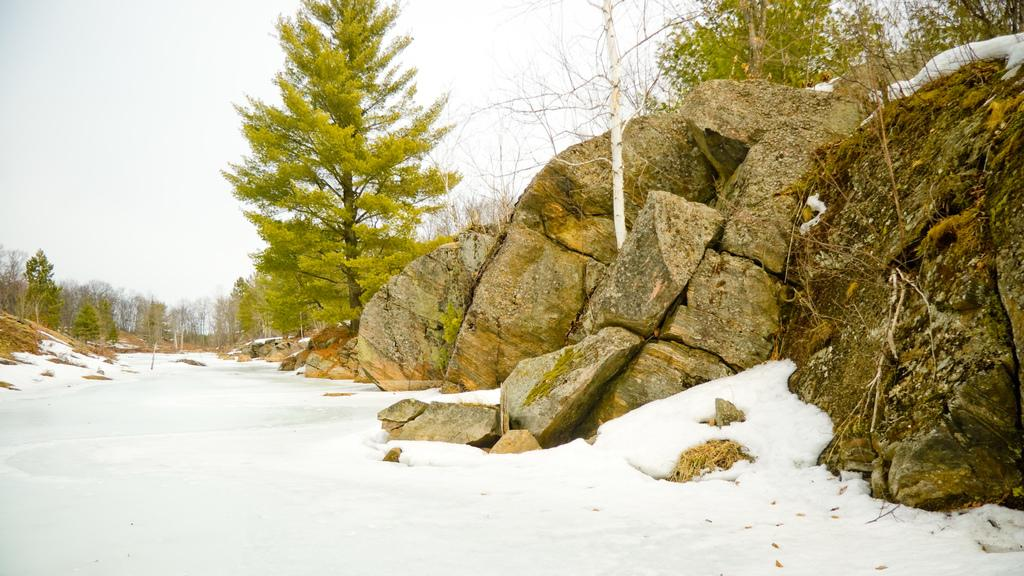What type of natural elements can be seen in the image? There are trees and rocks in the image. What is the ground covered with at the bottom of the image? There is snow at the bottom of the image. What part of the natural environment is visible in the image? The sky is visible at the top of the image. Can you see any visitors from space in the image? There are no visitors from space visible in the image. What type of wilderness can be seen in the image? The image does not depict a specific type of wilderness; it simply shows trees, rocks, snow, and sky. 